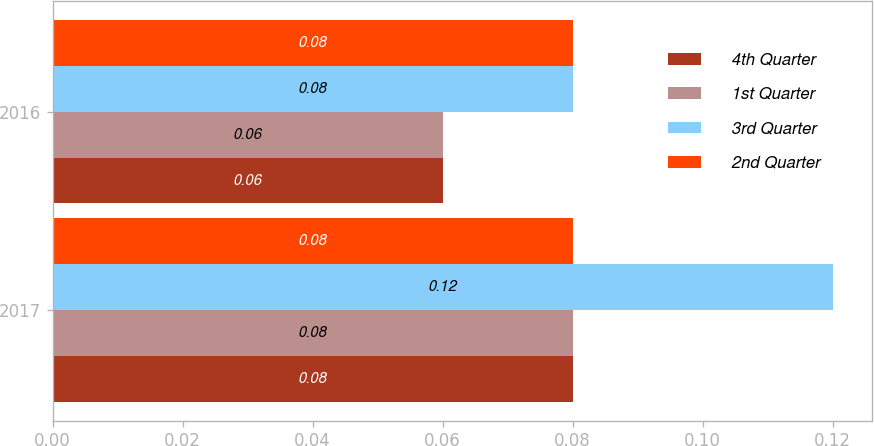Convert chart to OTSL. <chart><loc_0><loc_0><loc_500><loc_500><stacked_bar_chart><ecel><fcel>2017<fcel>2016<nl><fcel>4th Quarter<fcel>0.08<fcel>0.06<nl><fcel>1st Quarter<fcel>0.08<fcel>0.06<nl><fcel>3rd Quarter<fcel>0.12<fcel>0.08<nl><fcel>2nd Quarter<fcel>0.08<fcel>0.08<nl></chart> 